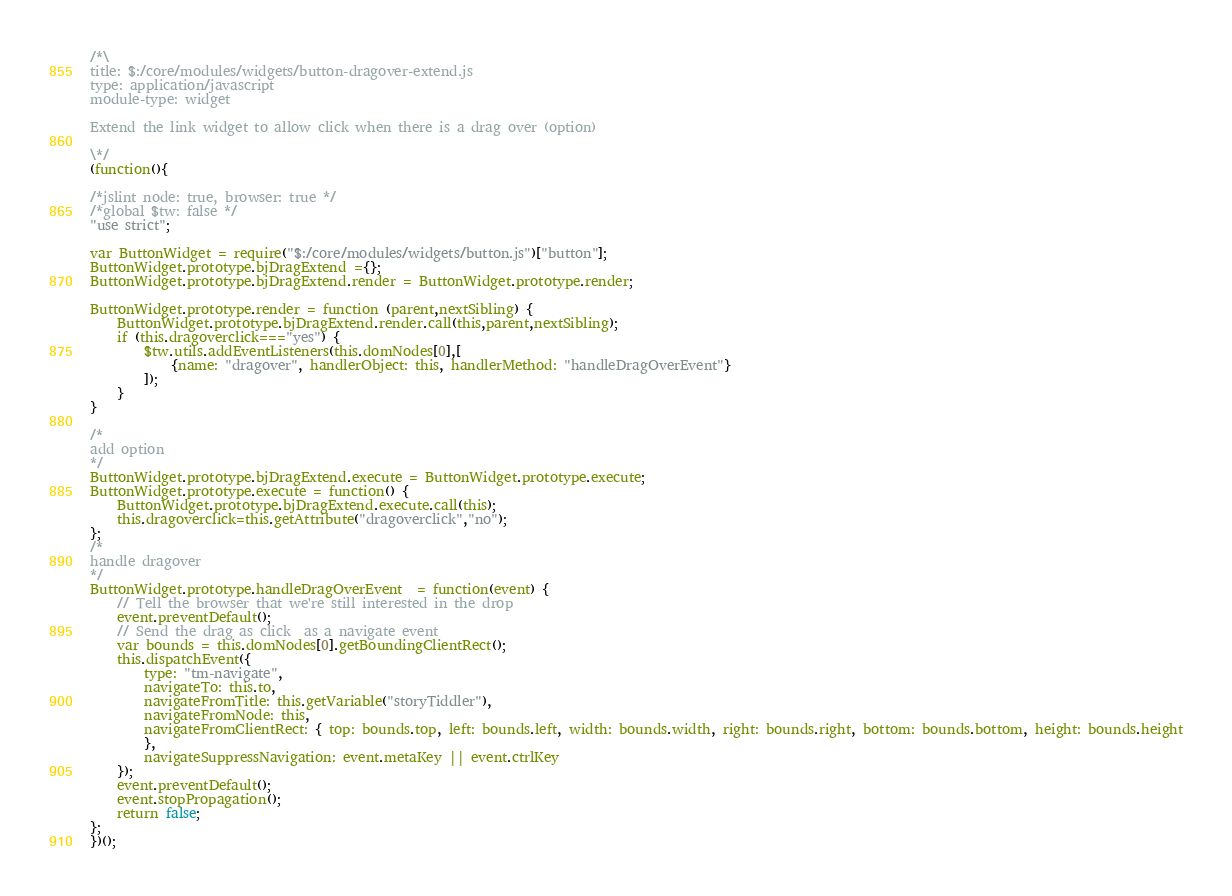Convert code to text. <code><loc_0><loc_0><loc_500><loc_500><_JavaScript_>/*\
title: $:/core/modules/widgets/button-dragover-extend.js
type: application/javascript
module-type: widget

Extend the link widget to allow click when there is a drag over (option)

\*/
(function(){

/*jslint node: true, browser: true */
/*global $tw: false */
"use strict";

var ButtonWidget = require("$:/core/modules/widgets/button.js")["button"];
ButtonWidget.prototype.bjDragExtend ={};
ButtonWidget.prototype.bjDragExtend.render = ButtonWidget.prototype.render;

ButtonWidget.prototype.render = function (parent,nextSibling) {
	ButtonWidget.prototype.bjDragExtend.render.call(this,parent,nextSibling);
	if (this.dragoverclick==="yes") { 
		$tw.utils.addEventListeners(this.domNodes[0],[
			{name: "dragover", handlerObject: this, handlerMethod: "handleDragOverEvent"}
		]);
	}
}

/*
add option
*/
ButtonWidget.prototype.bjDragExtend.execute = ButtonWidget.prototype.execute;
ButtonWidget.prototype.execute = function() {
	ButtonWidget.prototype.bjDragExtend.execute.call(this);
	this.dragoverclick=this.getAttribute("dragoverclick","no");
};
/*
handle dragover
*/
ButtonWidget.prototype.handleDragOverEvent  = function(event) {
	// Tell the browser that we're still interested in the drop
	event.preventDefault();
	// Send the drag as click  as a navigate event
	var bounds = this.domNodes[0].getBoundingClientRect();
	this.dispatchEvent({
		type: "tm-navigate",
		navigateTo: this.to,
		navigateFromTitle: this.getVariable("storyTiddler"),
		navigateFromNode: this,
		navigateFromClientRect: { top: bounds.top, left: bounds.left, width: bounds.width, right: bounds.right, bottom: bounds.bottom, height: bounds.height
		},
		navigateSuppressNavigation: event.metaKey || event.ctrlKey
	});
	event.preventDefault();
	event.stopPropagation();
	return false;
};
})();
</code> 